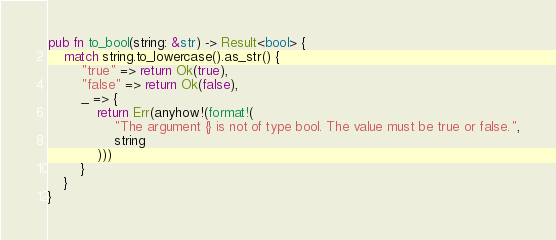<code> <loc_0><loc_0><loc_500><loc_500><_Rust_>
pub fn to_bool(string: &str) -> Result<bool> {
    match string.to_lowercase().as_str() {
        "true" => return Ok(true),
        "false" => return Ok(false),
        _ => {
            return Err(anyhow!(format!(
                "The argument {} is not of type bool. The value must be true or false.",
                string
            )))
        }
    }
}
</code> 